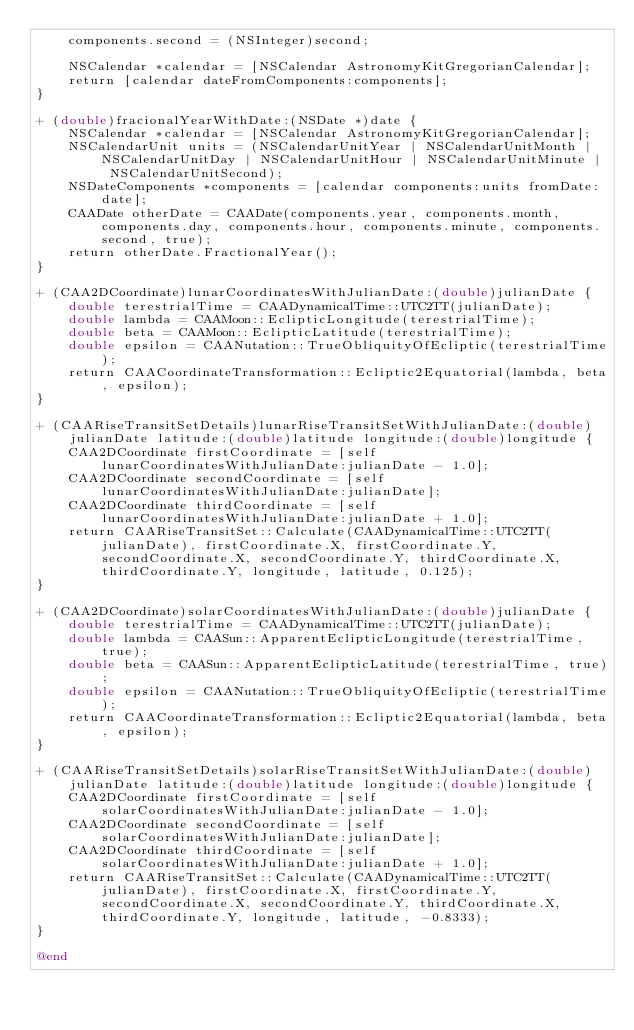Convert code to text. <code><loc_0><loc_0><loc_500><loc_500><_ObjectiveC_>    components.second = (NSInteger)second;
    
    NSCalendar *calendar = [NSCalendar AstronomyKitGregorianCalendar];
    return [calendar dateFromComponents:components];
}

+ (double)fracionalYearWithDate:(NSDate *)date {
    NSCalendar *calendar = [NSCalendar AstronomyKitGregorianCalendar];
    NSCalendarUnit units = (NSCalendarUnitYear | NSCalendarUnitMonth | NSCalendarUnitDay | NSCalendarUnitHour | NSCalendarUnitMinute | NSCalendarUnitSecond);
    NSDateComponents *components = [calendar components:units fromDate:date];
    CAADate otherDate = CAADate(components.year, components.month, components.day, components.hour, components.minute, components.second, true);
    return otherDate.FractionalYear();
}

+ (CAA2DCoordinate)lunarCoordinatesWithJulianDate:(double)julianDate {
    double terestrialTime = CAADynamicalTime::UTC2TT(julianDate);
    double lambda = CAAMoon::EclipticLongitude(terestrialTime);
    double beta = CAAMoon::EclipticLatitude(terestrialTime);
    double epsilon = CAANutation::TrueObliquityOfEcliptic(terestrialTime);
    return CAACoordinateTransformation::Ecliptic2Equatorial(lambda, beta, epsilon);
}

+ (CAARiseTransitSetDetails)lunarRiseTransitSetWithJulianDate:(double)julianDate latitude:(double)latitude longitude:(double)longitude {
    CAA2DCoordinate firstCoordinate = [self lunarCoordinatesWithJulianDate:julianDate - 1.0];
    CAA2DCoordinate secondCoordinate = [self lunarCoordinatesWithJulianDate:julianDate];
    CAA2DCoordinate thirdCoordinate = [self lunarCoordinatesWithJulianDate:julianDate + 1.0];
    return CAARiseTransitSet::Calculate(CAADynamicalTime::UTC2TT(julianDate), firstCoordinate.X, firstCoordinate.Y, secondCoordinate.X, secondCoordinate.Y, thirdCoordinate.X, thirdCoordinate.Y, longitude, latitude, 0.125);
}

+ (CAA2DCoordinate)solarCoordinatesWithJulianDate:(double)julianDate {
    double terestrialTime = CAADynamicalTime::UTC2TT(julianDate);
    double lambda = CAASun::ApparentEclipticLongitude(terestrialTime, true);
    double beta = CAASun::ApparentEclipticLatitude(terestrialTime, true);
    double epsilon = CAANutation::TrueObliquityOfEcliptic(terestrialTime);
    return CAACoordinateTransformation::Ecliptic2Equatorial(lambda, beta, epsilon);
}

+ (CAARiseTransitSetDetails)solarRiseTransitSetWithJulianDate:(double)julianDate latitude:(double)latitude longitude:(double)longitude {
    CAA2DCoordinate firstCoordinate = [self solarCoordinatesWithJulianDate:julianDate - 1.0];
    CAA2DCoordinate secondCoordinate = [self solarCoordinatesWithJulianDate:julianDate];
    CAA2DCoordinate thirdCoordinate = [self solarCoordinatesWithJulianDate:julianDate + 1.0];
    return CAARiseTransitSet::Calculate(CAADynamicalTime::UTC2TT(julianDate), firstCoordinate.X, firstCoordinate.Y, secondCoordinate.X, secondCoordinate.Y, thirdCoordinate.X, thirdCoordinate.Y, longitude, latitude, -0.8333);
}

@end
</code> 